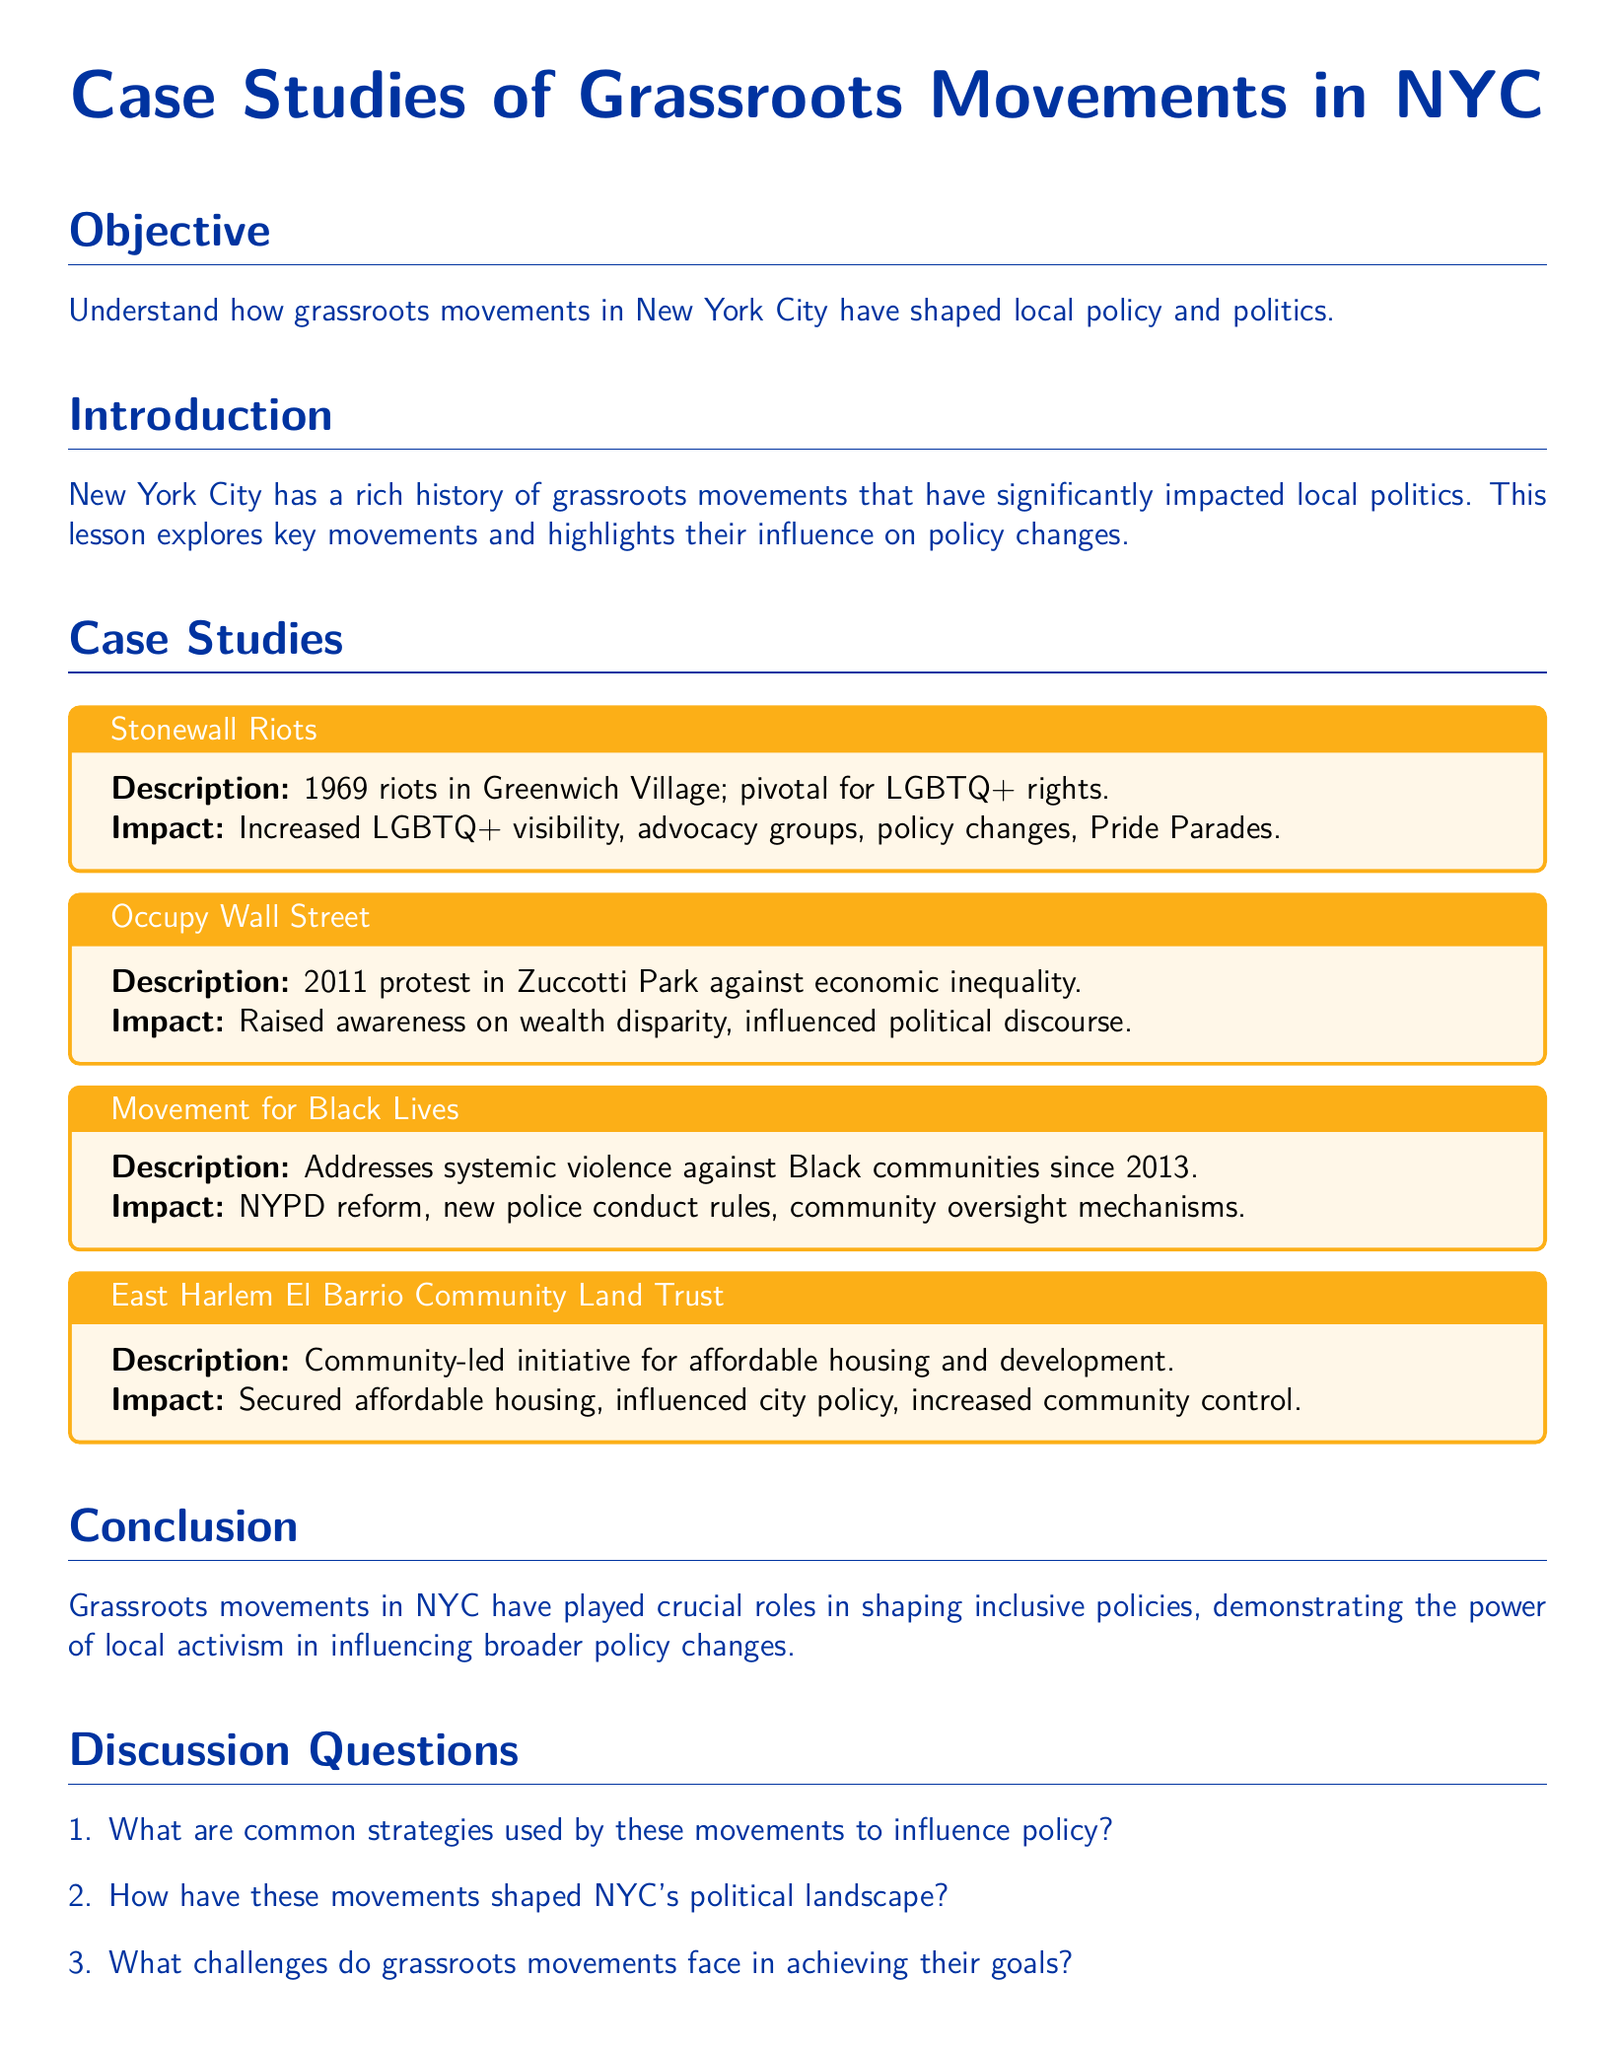What year did the Stonewall Riots occur? The document states that the Stonewall Riots happened in 1969.
Answer: 1969 What movement took place in Zuccotti Park? The document mentions Occupy Wall Street as the movement that took place in Zuccotti Park in 2011.
Answer: Occupy Wall Street Which initiative focuses on community-led affordable housing? The East Harlem El Barrio Community Land Trust is mentioned as the initiative focused on affordable housing.
Answer: East Harlem El Barrio Community Land Trust What impact did the Movement for Black Lives have on police conduct? The document states that the Movement for Black Lives led to new police conduct rules.
Answer: New police conduct rules What common theme is discussed across all case studies? The common theme is the influence of grassroots movements on local policy changes in NYC.
Answer: Influence on local policy changes What is the primary goal of grassroots movements according to the lesson? The primary goal mentioned is shaping inclusive policies in NYC.
Answer: Shaping inclusive policies What type of document is this? The document is a lesson plan focused on case studies.
Answer: Lesson plan What is one challenge that grassroots movements face? One challenge mentioned is the difficulty in achieving their goals.
Answer: Achieving their goals 